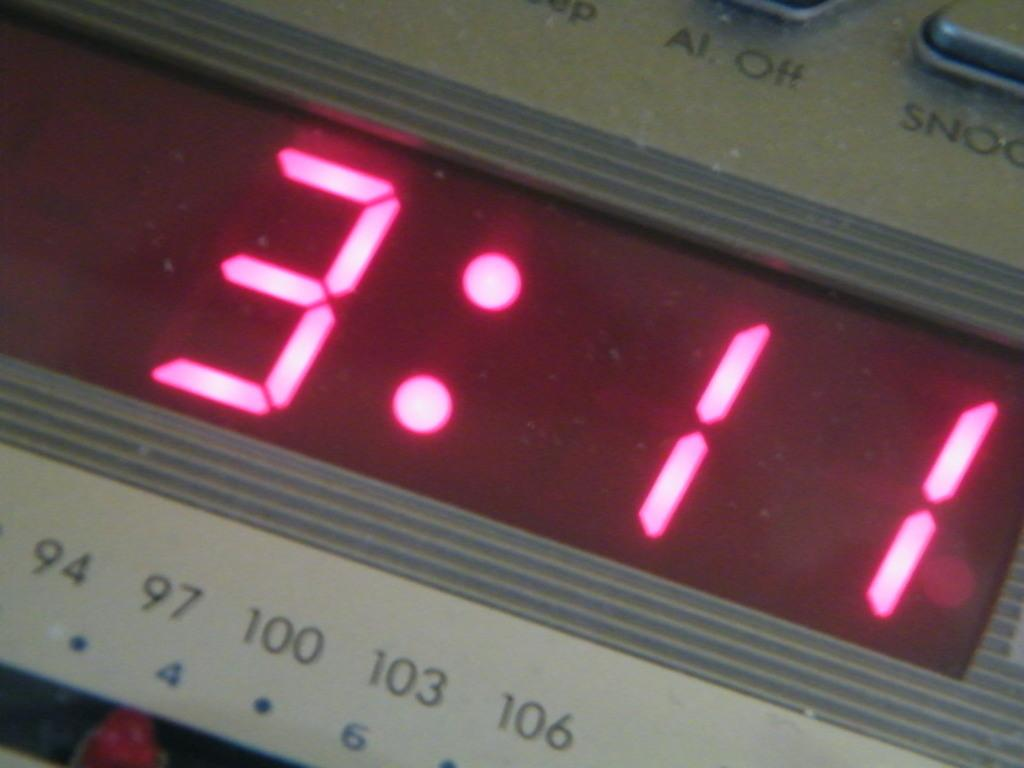Provide a one-sentence caption for the provided image. A digital clock displauing the time in red numbers. 